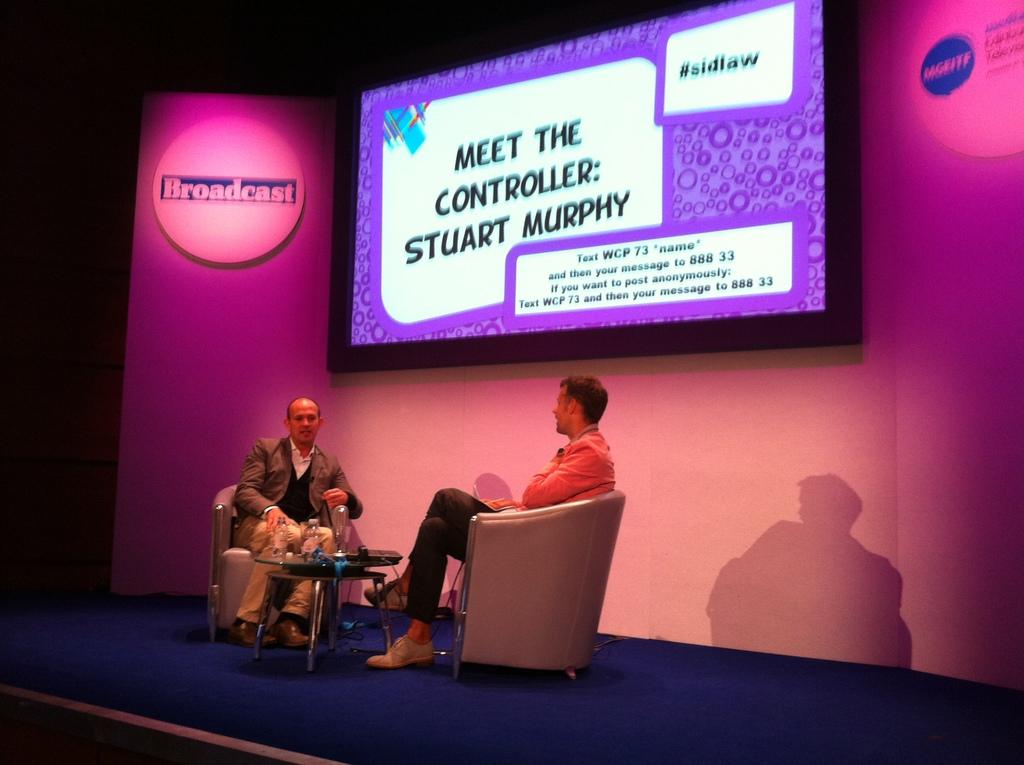How many people are sitting on chairs in the image? There are two men sitting on chairs in the image. What is the location of the table in the image? The table is on stage in the image. What can be found on the table? There are bottles and some objects on the table. What additional features are present in the image? There is a screen and a banner in the image. How would you describe the lighting in the image? The background of the image is dark. What type of servant is standing behind the men in the image? There is no servant present in the image; only the two men sitting on chairs, the table, bottles, objects, screen, and banner are visible. 